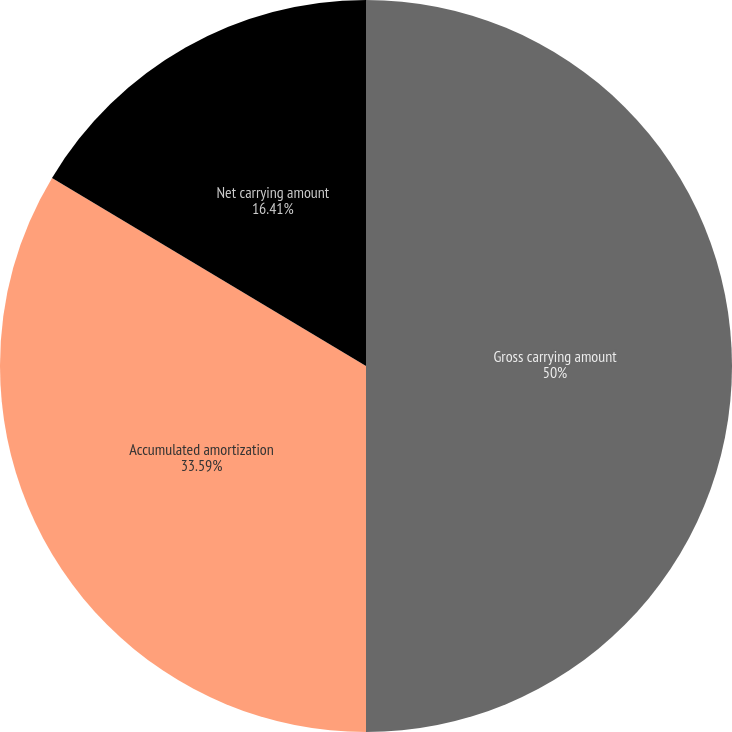Convert chart to OTSL. <chart><loc_0><loc_0><loc_500><loc_500><pie_chart><fcel>Gross carrying amount<fcel>Accumulated amortization<fcel>Net carrying amount<nl><fcel>50.0%<fcel>33.59%<fcel>16.41%<nl></chart> 